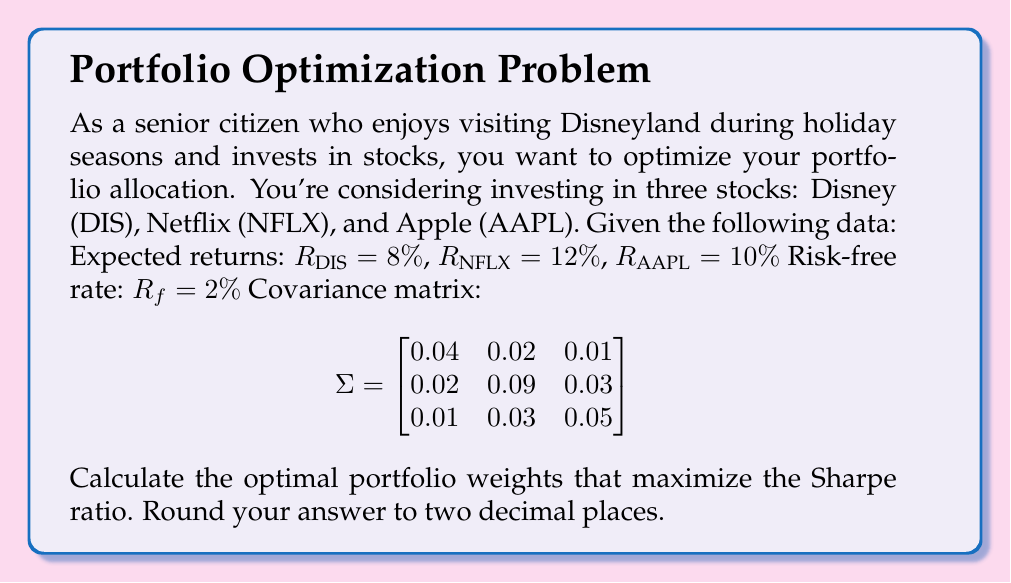Can you answer this question? To find the optimal portfolio allocation using the Sharpe ratio and covariance matrix, we'll follow these steps:

1) First, we need to calculate the excess returns for each stock:
   $E[R_i] - R_f$ for $i = DIS, NFLX, AAPL$
   
   $E[R_{DIS}] - R_f = 8\% - 2\% = 6\%$
   $E[R_{NFLX}] - R_f = 12\% - 2\% = 10\%$
   $E[R_{AAPL}] - R_f = 10\% - 2\% = 8\%$

2) We form the excess return vector:
   $$\mu = \begin{bmatrix} 0.06 \\ 0.10 \\ 0.08 \end{bmatrix}$$

3) The optimal portfolio weights that maximize the Sharpe ratio are given by:
   $$w = \frac{\Sigma^{-1}\mu}{\mathbf{1}^T\Sigma^{-1}\mu}$$
   
   where $\Sigma^{-1}$ is the inverse of the covariance matrix and $\mathbf{1}$ is a vector of ones.

4) We need to calculate $\Sigma^{-1}$:
   $$\Sigma^{-1} = \begin{bmatrix}
   28.7037 & -5.5556 & -2.7778 \\
   -5.5556 & 13.8889 & -5.5556 \\
   -2.7778 & -5.5556 & 23.1481
   \end{bmatrix}$$

5) Now we can calculate $\Sigma^{-1}\mu$:
   $$\Sigma^{-1}\mu = \begin{bmatrix}
   28.7037 & -5.5556 & -2.7778 \\
   -5.5556 & 13.8889 & -5.5556 \\
   -2.7778 & -5.5556 & 23.1481
   \end{bmatrix} \begin{bmatrix} 0.06 \\ 0.10 \\ 0.08 \end{bmatrix} = \begin{bmatrix} 1.2222 \\ 0.7778 \\ 1.0000 \end{bmatrix}$$

6) Calculate $\mathbf{1}^T\Sigma^{-1}\mu$:
   $$\mathbf{1}^T\Sigma^{-1}\mu = 1.2222 + 0.7778 + 1.0000 = 3.0000$$

7) Finally, we can calculate the optimal weights:
   $$w = \frac{\Sigma^{-1}\mu}{\mathbf{1}^T\Sigma^{-1}\mu} = \frac{1}{3.0000} \begin{bmatrix} 1.2222 \\ 0.7778 \\ 1.0000 \end{bmatrix} = \begin{bmatrix} 0.4074 \\ 0.2593 \\ 0.3333 \end{bmatrix}$$

Rounding to two decimal places, we get the final weights.
Answer: The optimal portfolio weights that maximize the Sharpe ratio are:
Disney (DIS): 0.41
Netflix (NFLX): 0.26
Apple (AAPL): 0.33 